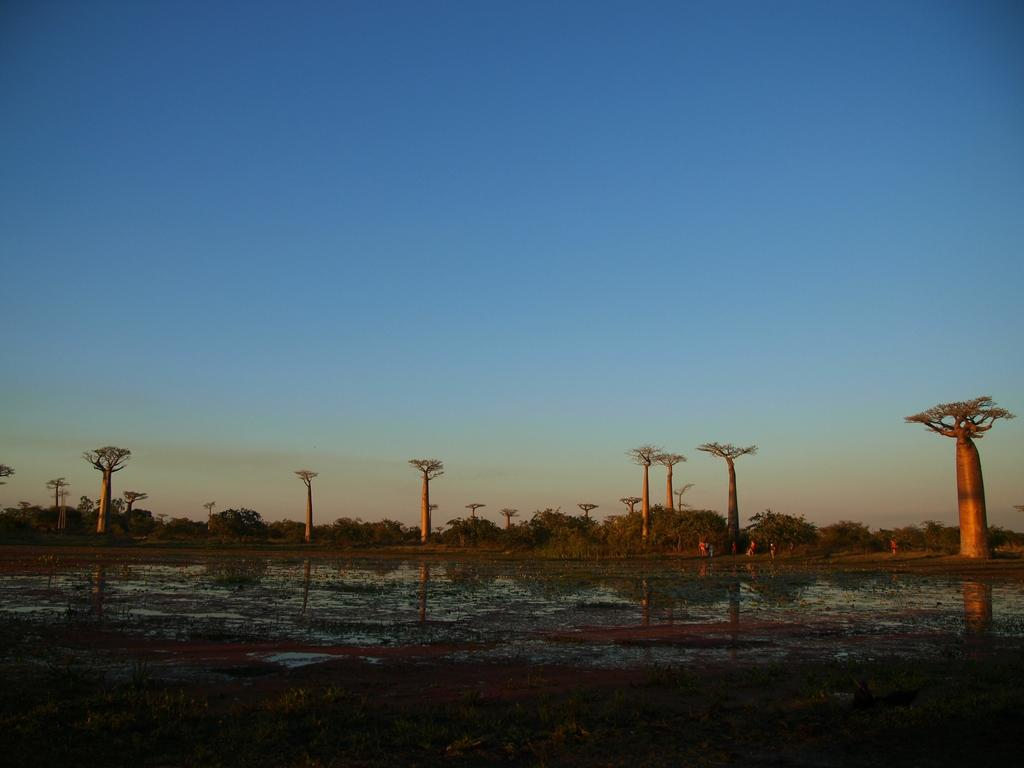What is present on the ground at the bottom of the image? There is water on the ground at the bottom of the image. What can be seen in the distance in the image? There are trees in the background of the image. What else is visible in the background of the image? There are persons standing on the ground in the background of the image. What is visible above the trees and persons in the image? The sky is visible in the background of the image. Can you tell me how much money is being exchanged between the persons in the image? There is no indication of money or any exchange taking place in the image. 